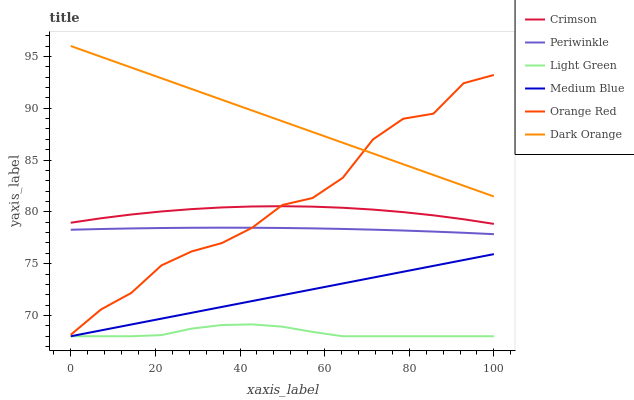Does Medium Blue have the minimum area under the curve?
Answer yes or no. No. Does Medium Blue have the maximum area under the curve?
Answer yes or no. No. Is Periwinkle the smoothest?
Answer yes or no. No. Is Periwinkle the roughest?
Answer yes or no. No. Does Periwinkle have the lowest value?
Answer yes or no. No. Does Medium Blue have the highest value?
Answer yes or no. No. Is Periwinkle less than Dark Orange?
Answer yes or no. Yes. Is Orange Red greater than Light Green?
Answer yes or no. Yes. Does Periwinkle intersect Dark Orange?
Answer yes or no. No. 